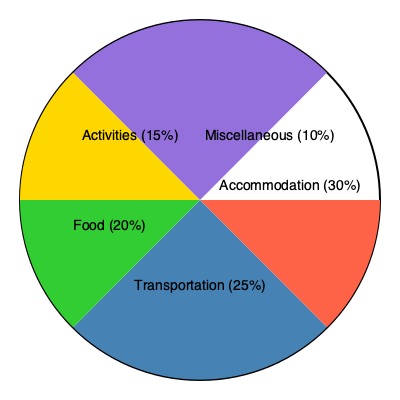Given the pie chart of vacation expenses for a family trip, if the total budget is $5,000, how much should be allocated for food and activities combined? To solve this problem, we need to follow these steps:

1. Identify the percentages for food and activities from the pie chart:
   - Food: 20%
   - Activities: 15%

2. Calculate the combined percentage:
   $20\% + 15\% = 35\%$

3. Convert the percentage to a decimal:
   $35\% = 0.35$

4. Multiply the total budget by the decimal to get the amount for food and activities:
   $\$5,000 \times 0.35 = \$1,750$

Therefore, the amount that should be allocated for food and activities combined is $1,750.
Answer: $1,750 